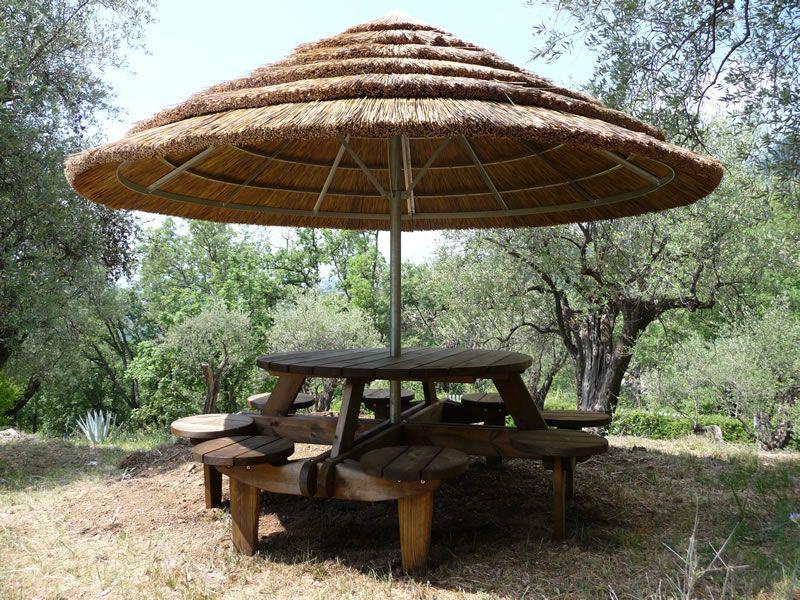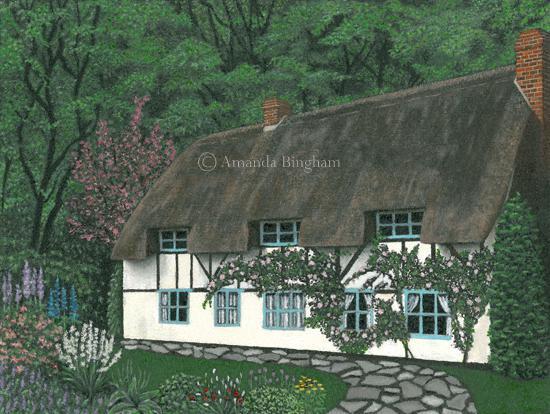The first image is the image on the left, the second image is the image on the right. For the images displayed, is the sentence "One image shows a thatched umbrella shape over a seating area with a round table." factually correct? Answer yes or no. Yes. The first image is the image on the left, the second image is the image on the right. For the images shown, is this caption "In the left image a table is covered by a roof." true? Answer yes or no. Yes. 